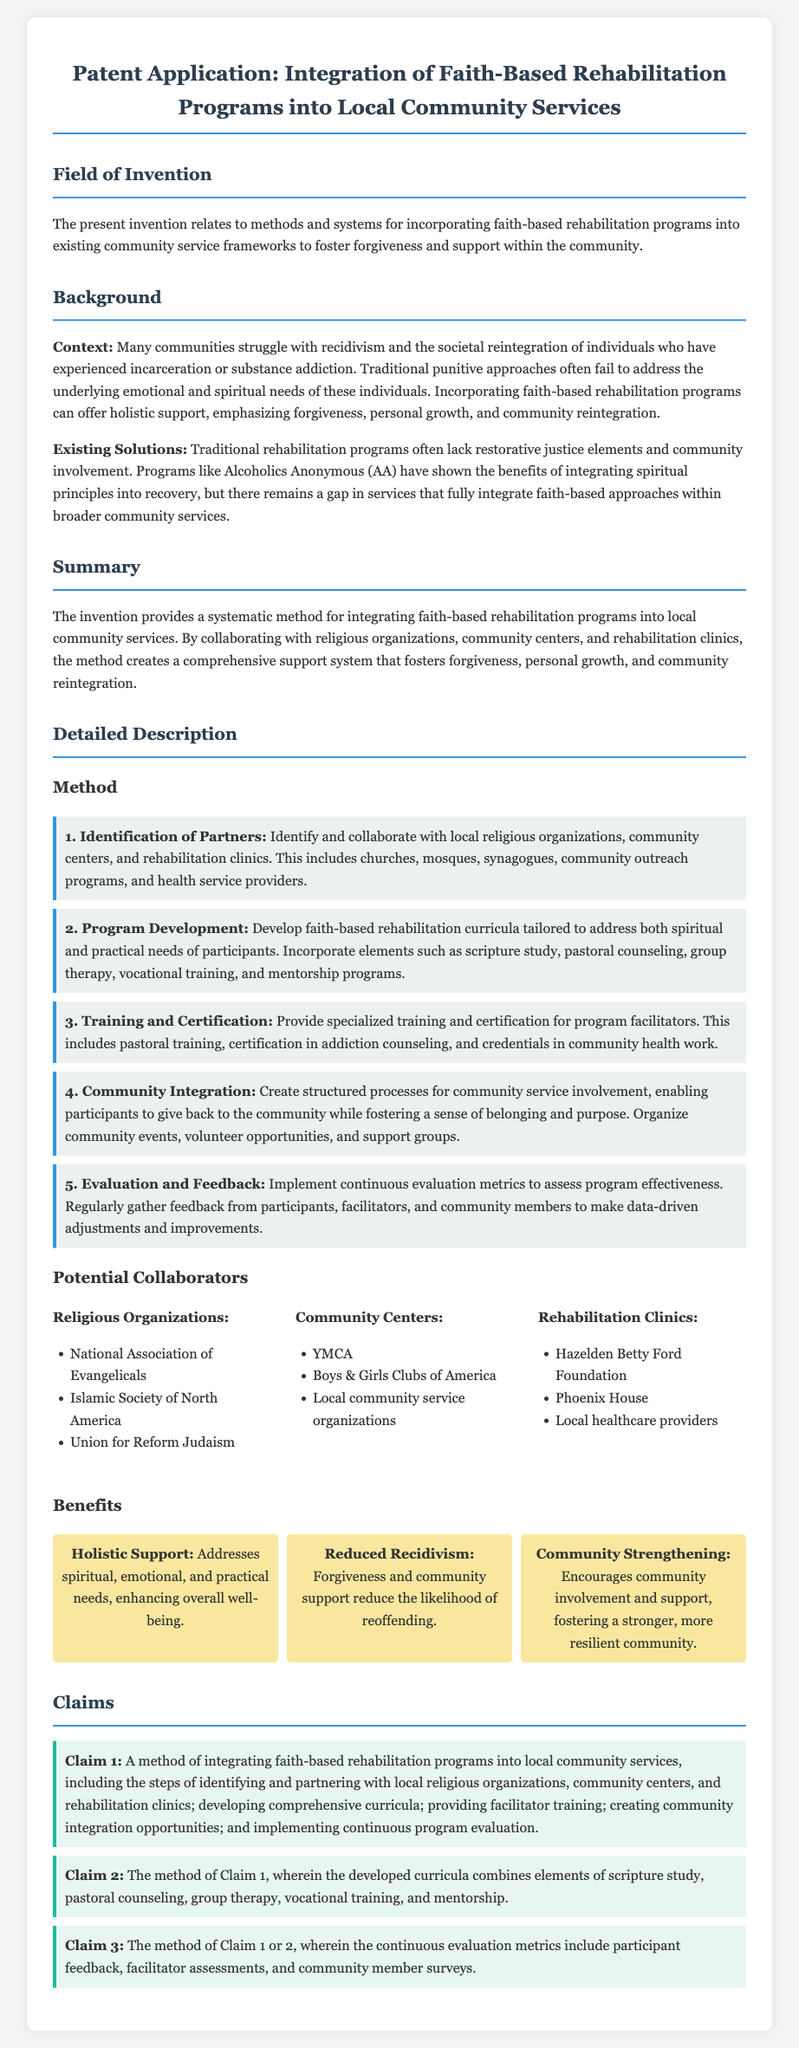what is the title of the patent application? The title is stated at the beginning of the document as the main heading.
Answer: Integration of Faith-Based Rehabilitation Programs into Local Community Services what is the first step in the method described? The first step outlines the initial action necessary for the integration method.
Answer: Identification of Partners name one organization listed as a potential collaborator under religious organizations. The document provides examples of organizations that can collaborate in this initiative.
Answer: National Association of Evangelicals what is one benefit mentioned in the document? The document lists various benefits of the proposed program, focusing on community and individual outcomes.
Answer: Holistic Support how many claims are there in the patent application? The claims section specifies the number of unique claims made by the invention.
Answer: 3 which existing program is referenced as an example of integrating spiritual principles? One program is highlighted as having previously integrated spiritual aspects in its methodology.
Answer: Alcoholics Anonymous (AA) what area does the invention aim to address? This reflects the overall purpose of the invention in context.
Answer: Recidivism and societal reintegration what element is included in the developed curricula? The curricula are stated to contain specific components aimed at participant support.
Answer: Scripture study 